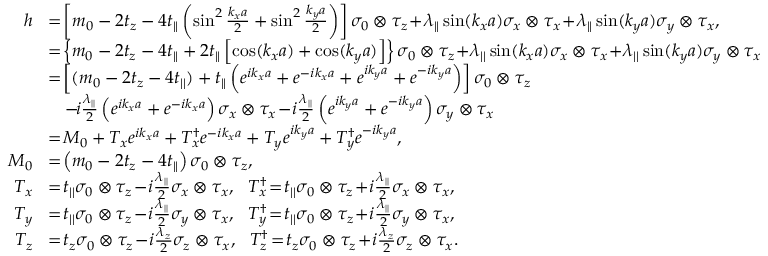Convert formula to latex. <formula><loc_0><loc_0><loc_500><loc_500>\begin{array} { r l } { h } & { \, = \, \left [ m _ { 0 } - 2 t _ { z } - 4 t _ { | | } \left ( \sin ^ { 2 } \frac { k _ { x } a } { 2 } + \sin ^ { 2 } \frac { k _ { y } a } { 2 } \right ) \right ] \sigma _ { 0 } \otimes \tau _ { z } \, + \, \lambda _ { | | } \sin ( k _ { x } a ) \sigma _ { x } \otimes \tau _ { x } \, + \, \lambda _ { | | } \sin ( k _ { y } a ) \sigma _ { y } \otimes \tau _ { x } , } \\ & { \, = \, \left \{ m _ { 0 } - 2 t _ { z } - 4 t _ { | | } + 2 t _ { | | } \left [ \cos ( k _ { x } a ) + \cos ( k _ { y } a ) \right ] \right \} \sigma _ { 0 } \otimes \tau _ { z } \, + \, \lambda _ { | | } \sin ( k _ { x } a ) \sigma _ { x } \otimes \tau _ { x } \, + \, \lambda _ { | | } \sin ( k _ { y } a ) \sigma _ { y } \otimes \tau _ { x } } \\ & { \, = \, \left [ ( m _ { 0 } - 2 t _ { z } - 4 t _ { | | } ) + t _ { | | } \left ( e ^ { i k _ { x } a } + e ^ { - i k _ { x } a } + e ^ { i k _ { y } a } + e ^ { - i k _ { y } a } \right ) \right ] \sigma _ { 0 } \otimes \tau _ { z } } \\ & { \, - \, i \frac { \lambda _ { | | } } { 2 } \left ( e ^ { i k _ { x } a } + e ^ { - i k _ { x } a } \right ) \sigma _ { x } \otimes \tau _ { x } \, - \, i \frac { \lambda _ { | | } } { 2 } \left ( e ^ { i k _ { y } a } + e ^ { - i k _ { y } a } \right ) \sigma _ { y } \otimes \tau _ { x } } \\ & { \, = \, M _ { 0 } + T _ { x } e ^ { i k _ { x } a } + T _ { x } ^ { \dagger } e ^ { - i k _ { x } a } + T _ { y } e ^ { i k _ { y } a } + T _ { y } ^ { \dagger } e ^ { - i k _ { y } a } , } \\ { M _ { 0 } } & { \, = \, \left ( m _ { 0 } - 2 t _ { z } - 4 t _ { | | } \right ) \sigma _ { 0 } \otimes \tau _ { z } , } \\ { T _ { x } } & { \, = \, t _ { | | } \sigma _ { 0 } \otimes \tau _ { z } \, - \, i \frac { \lambda _ { | | } } { 2 } \sigma _ { x } \otimes \tau _ { x } , T _ { x } ^ { \dagger } \, = \, t _ { | | } \sigma _ { 0 } \otimes \tau _ { z } \, + \, i \frac { \lambda _ { | | } } { 2 } \sigma _ { x } \otimes \tau _ { x } , } \\ { T _ { y } } & { \, = \, t _ { | | } \sigma _ { 0 } \otimes \tau _ { z } \, - \, i \frac { \lambda _ { | | } } { 2 } \sigma _ { y } \otimes \tau _ { x } , T _ { y } ^ { \dagger } \, = \, t _ { | | } \sigma _ { 0 } \otimes \tau _ { z } \, + \, i \frac { \lambda _ { | | } } { 2 } \sigma _ { y } \otimes \tau _ { x } , } \\ { T _ { z } } & { \, = \, t _ { z } \sigma _ { 0 } \otimes \tau _ { z } \, - \, i \frac { \lambda _ { z } } { 2 } \sigma _ { z } \otimes \tau _ { x } , T _ { z } ^ { \dagger } \, = \, t _ { z } \sigma _ { 0 } \otimes \tau _ { z } \, + \, i \frac { \lambda _ { z } } { 2 } \sigma _ { z } \otimes \tau _ { x } . } \end{array}</formula> 